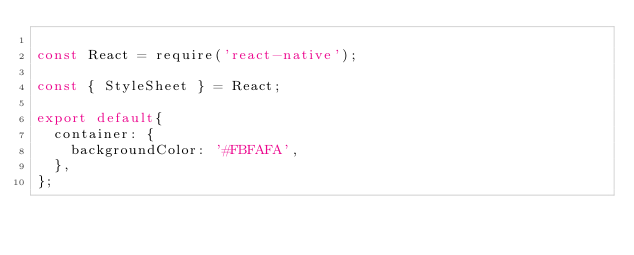Convert code to text. <code><loc_0><loc_0><loc_500><loc_500><_JavaScript_>
const React = require('react-native');

const { StyleSheet } = React;

export default{
  container: {
    backgroundColor: '#FBFAFA',
  },
};
</code> 